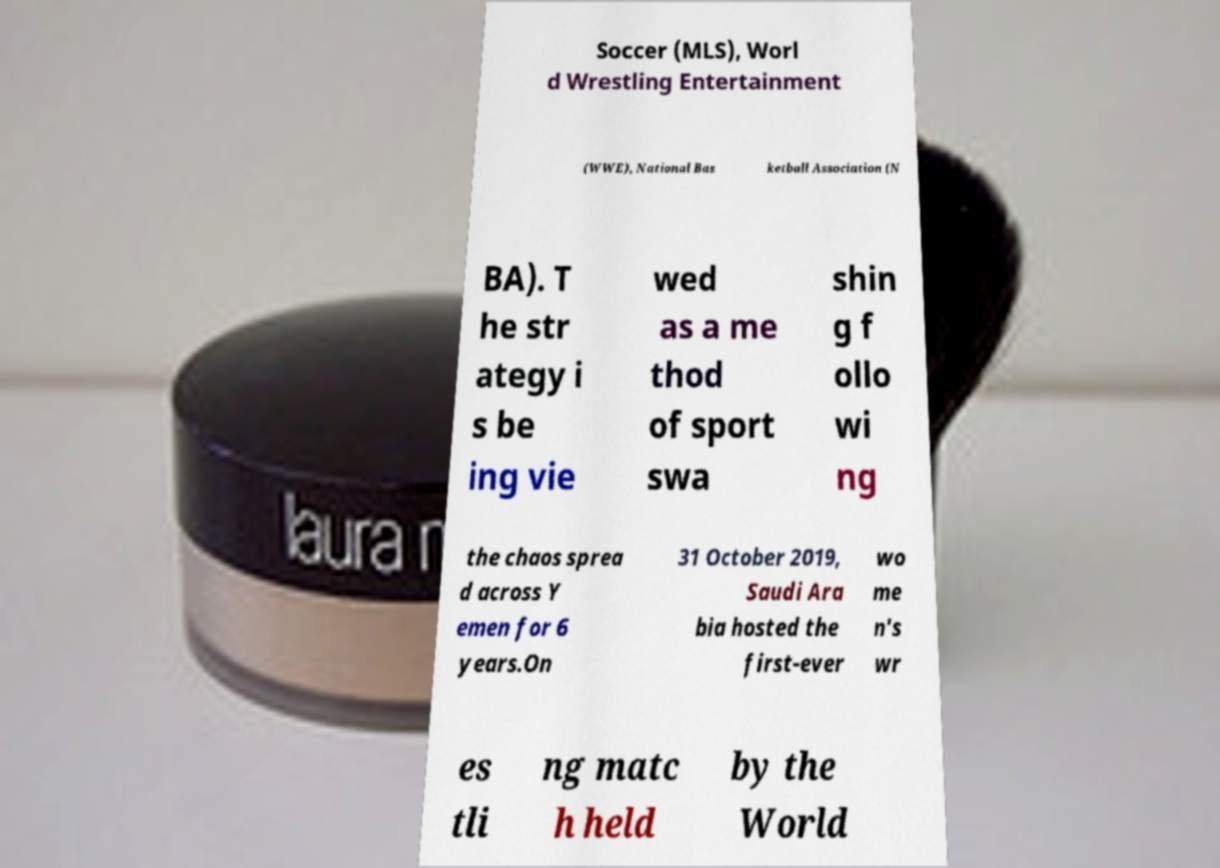Please read and relay the text visible in this image. What does it say? Soccer (MLS), Worl d Wrestling Entertainment (WWE), National Bas ketball Association (N BA). T he str ategy i s be ing vie wed as a me thod of sport swa shin g f ollo wi ng the chaos sprea d across Y emen for 6 years.On 31 October 2019, Saudi Ara bia hosted the first-ever wo me n's wr es tli ng matc h held by the World 